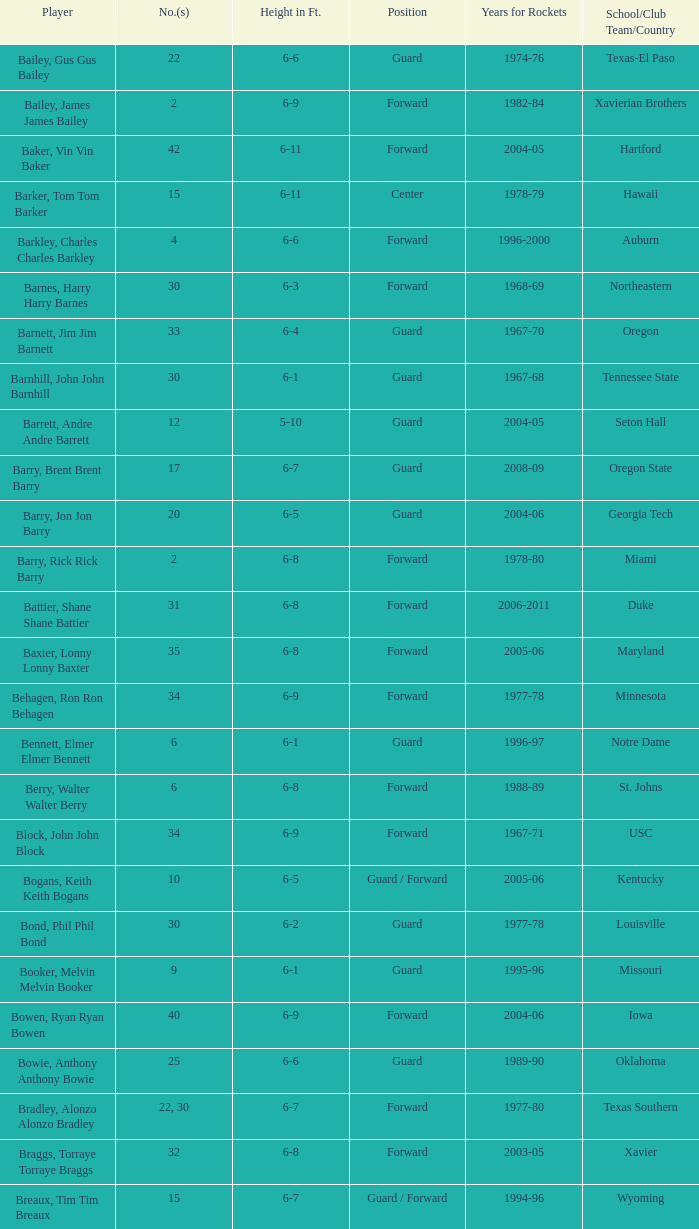What position is number 35 whose height is 6-6? Forward. 